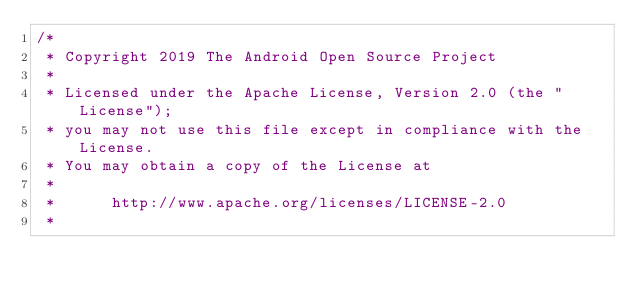<code> <loc_0><loc_0><loc_500><loc_500><_Kotlin_>/*
 * Copyright 2019 The Android Open Source Project
 *
 * Licensed under the Apache License, Version 2.0 (the "License");
 * you may not use this file except in compliance with the License.
 * You may obtain a copy of the License at
 *
 *      http://www.apache.org/licenses/LICENSE-2.0
 *</code> 